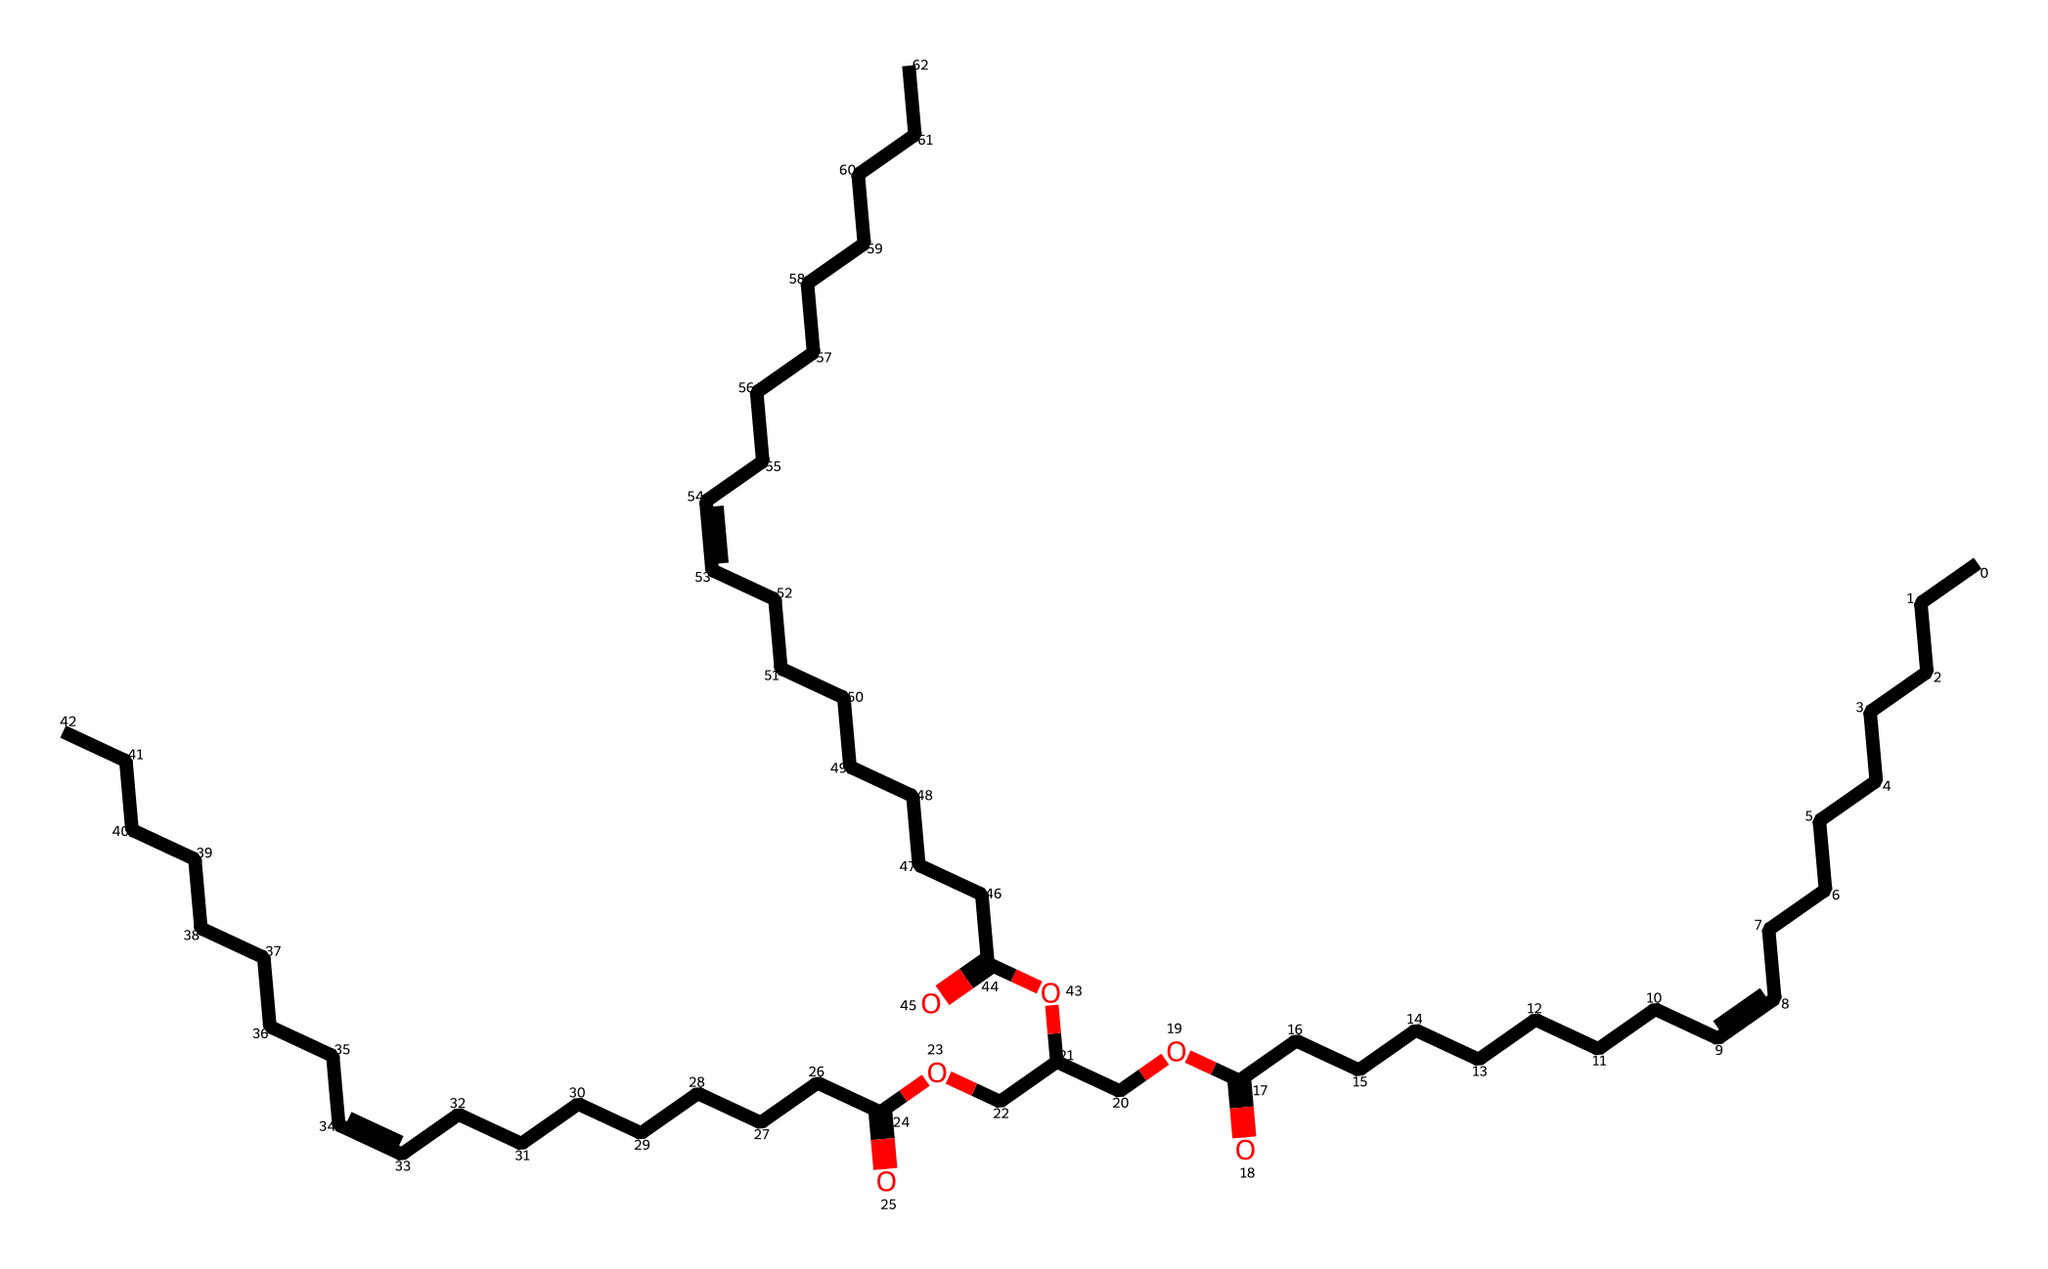What is the total number of carbon atoms in this chemical? The chemical can be analyzed by counting the 'C' symbols in the given SMILES representation. Each 'C' represents one carbon atom. By carefully identifying each segment, there are 36 carbon atoms total.
Answer: 36 How many double bonds are present in this chemical? In the SMILES, the double bonds are indicated by "/=C". By scanning the representation, we observe that there are three instances of double bonds throughout the structure.
Answer: 3 Is this compound a saturated or unsaturated fatty acid? The presence of double bonds in the structure indicates the compound is unsaturated. Saturated compounds have no double bonds. Therefore, the existence of double bonds confirms its unsaturation.
Answer: unsaturated What functional group is indicated by 'OCC' in the SMILES? The 'OCC' signifies an ether functional group because it contains an oxygen atom bonded to two carbon atoms. Ethers typically feature a structure where an oxygen is connected between two carbon chains.
Answer: ether Which part of the chemical structure suggests that it has a long-chain fatty acid character? The long carbon chains (more than 10 carbon atoms without branches) indicate that it has long-chain fatty acid properties. The extensive length of the carbon chains is characteristic of fatty acids derived from natural oils.
Answer: long-chain fatty acid What is the main characteristic of the compound due to the presence of carboxylic acid groups? The presence of the 'C(=O)O' segments in the structure indicates carboxylic acid groups. This functional group is known to contribute to the acidity of the compound when dissolved in water.
Answer: acidity 